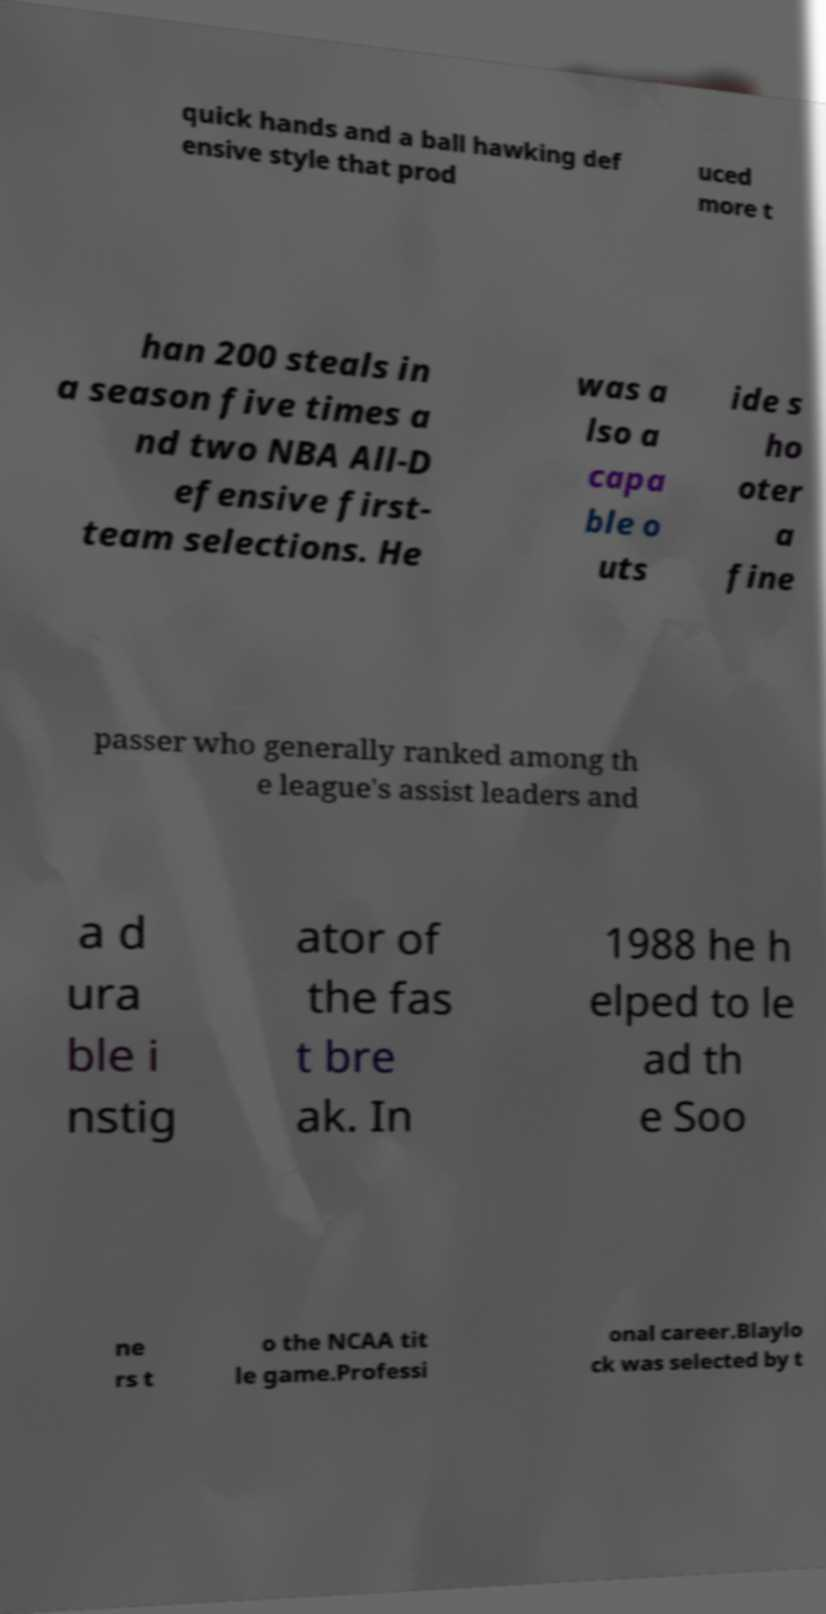For documentation purposes, I need the text within this image transcribed. Could you provide that? quick hands and a ball hawking def ensive style that prod uced more t han 200 steals in a season five times a nd two NBA All-D efensive first- team selections. He was a lso a capa ble o uts ide s ho oter a fine passer who generally ranked among th e league's assist leaders and a d ura ble i nstig ator of the fas t bre ak. In 1988 he h elped to le ad th e Soo ne rs t o the NCAA tit le game.Professi onal career.Blaylo ck was selected by t 